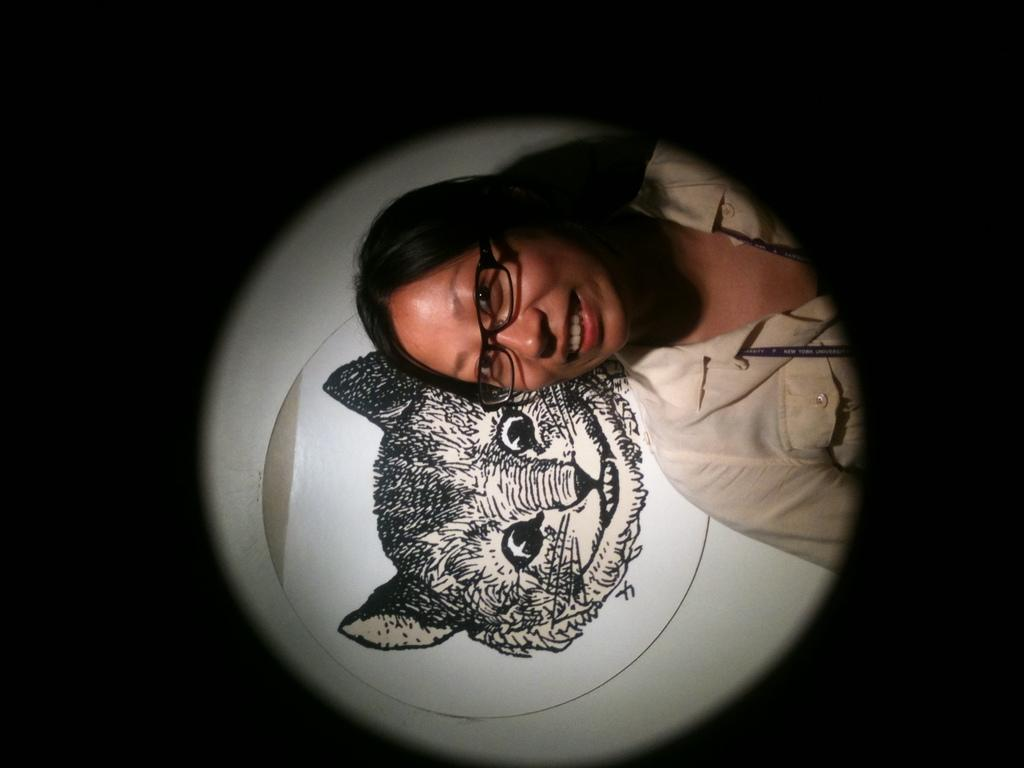Who is present in the image? There is a woman in the image. What is the woman wearing? The woman is wearing spectacles. What can be seen in the image besides the woman? There is a drawing of a cat in the image. How would you describe the lighting in the image? The surroundings in the image are dark. What type of shoes is the woman wearing in the image? There is no mention of shoes in the image, so we cannot determine the type of shoes the woman is wearing. 